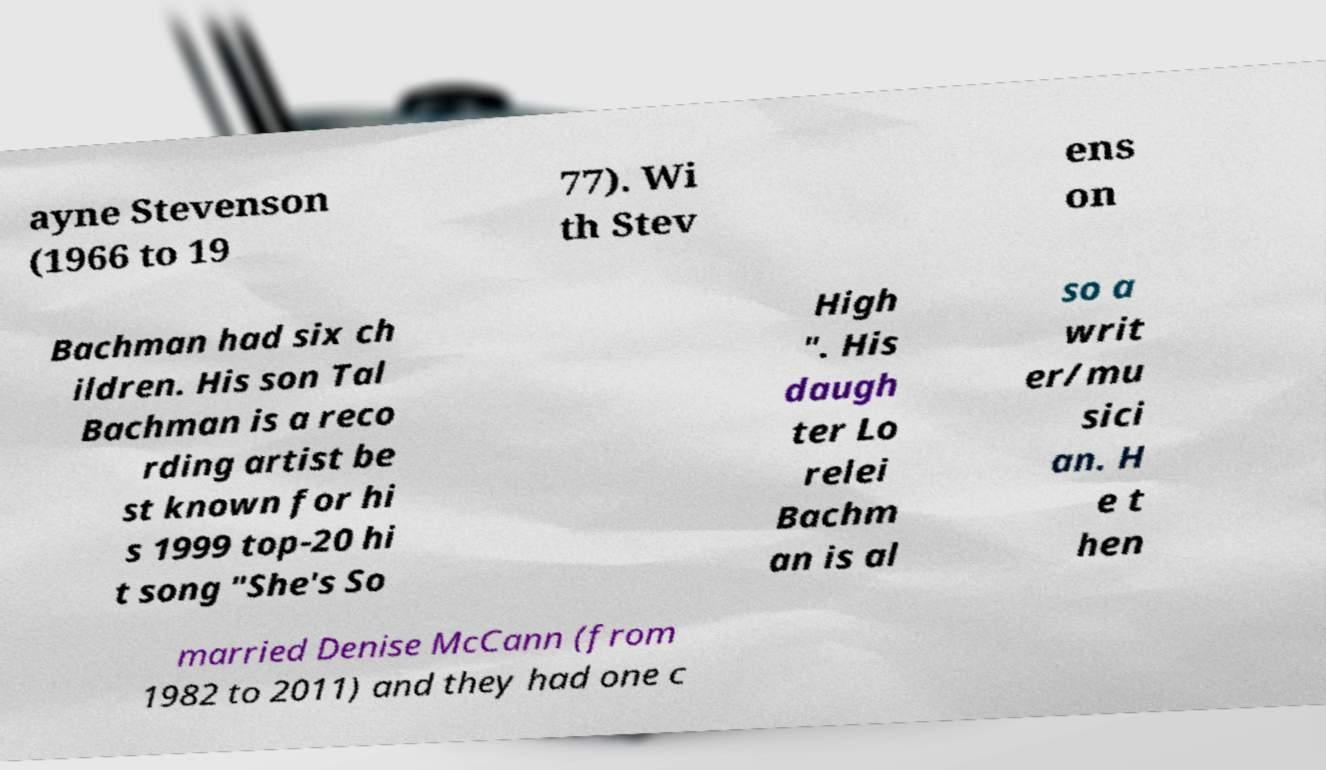What messages or text are displayed in this image? I need them in a readable, typed format. ayne Stevenson (1966 to 19 77). Wi th Stev ens on Bachman had six ch ildren. His son Tal Bachman is a reco rding artist be st known for hi s 1999 top-20 hi t song "She's So High ". His daugh ter Lo relei Bachm an is al so a writ er/mu sici an. H e t hen married Denise McCann (from 1982 to 2011) and they had one c 